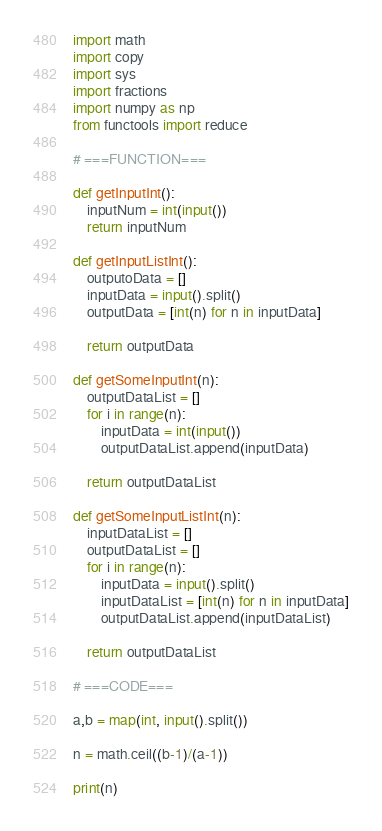Convert code to text. <code><loc_0><loc_0><loc_500><loc_500><_Python_>import math
import copy
import sys
import fractions
import numpy as np
from functools import reduce

# ===FUNCTION===

def getInputInt():
    inputNum = int(input())
    return inputNum

def getInputListInt():
    outputoData = []
    inputData = input().split()
    outputData = [int(n) for n in inputData]

    return outputData

def getSomeInputInt(n):
    outputDataList = []
    for i in range(n):
        inputData = int(input())
        outputDataList.append(inputData)

    return outputDataList

def getSomeInputListInt(n):
    inputDataList = []
    outputDataList = []
    for i in range(n):
        inputData = input().split()
        inputDataList = [int(n) for n in inputData]
        outputDataList.append(inputDataList)

    return outputDataList

# ===CODE===

a,b = map(int, input().split())

n = math.ceil((b-1)/(a-1))

print(n)</code> 